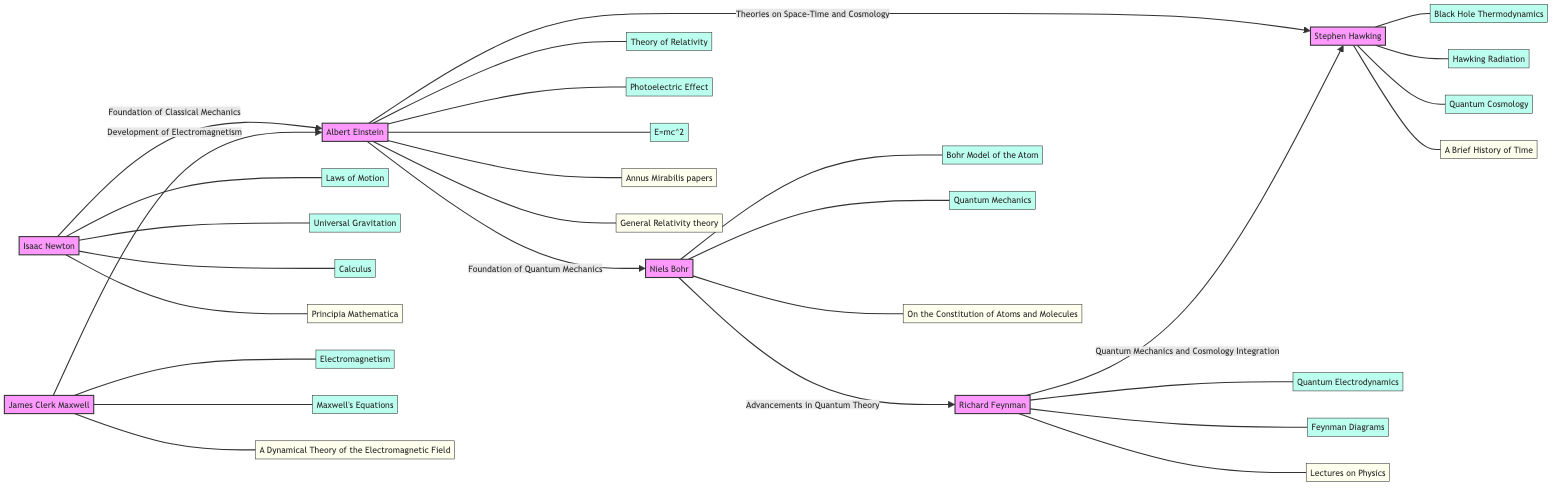What are the contributions of Stephen Hawking? The contributions of Stephen Hawking listed in the diagram are Black Hole Thermodynamics, Hawking Radiation, and Quantum Cosmology.
Answer: Black Hole Thermodynamics, Hawking Radiation, Quantum Cosmology Who is connected to Albert Einstein via the Development of Electromagnetism? According to the diagram, James Clerk Maxwell is connected to Albert Einstein with the relationship labeled as Development of Electromagnetism.
Answer: James Clerk Maxwell What type of relationship connects Isaac Newton to Albert Einstein? The diagram indicates that the relationship between Isaac Newton and Albert Einstein is characterized as the Foundation of Classical Mechanics.
Answer: Foundation of Classical Mechanics How many contributions are listed under Niels Bohr? The contributions under Niels Bohr in the diagram include Bohr Model of the Atom and Quantum Mechanics, giving a total of 2 contributions.
Answer: 2 What can be inferred about the connection between Richard Feynman and Stephen Hawking? The connection between Richard Feynman and Stephen Hawking is described as Quantum Mechanics and Cosmology Integration, suggesting the bridging of ideas in these domains.
Answer: Quantum Mechanics and Cosmology Integration What works are attributed to Albert Einstein? Albert Einstein's works in the diagram include Annus Mirabilis papers and General Relativity theory, with a total of 2 mentioned works.
Answer: Annus Mirabilis papers, General Relativity theory Which scientist contributed to the foundation of Quantum Mechanics? The diagram shows that Albert Einstein is credited with laying the foundation for Quantum Mechanics, connecting him to Niels Bohr.
Answer: Albert Einstein How many scientists are depicted in the diagram? The diagram illustrates a total of 6 scientists, including Isaac Newton, James Clerk Maxwell, Albert Einstein, Niels Bohr, Richard Feynman, and Stephen Hawking.
Answer: 6 